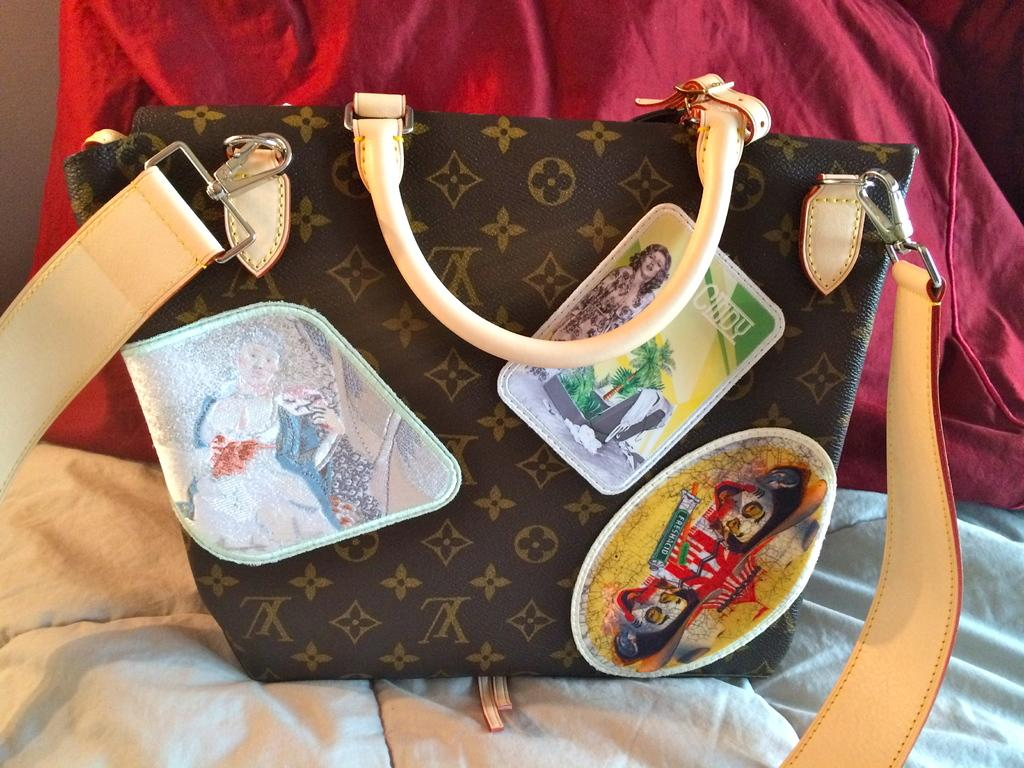What object is the main focus of the image? There is a handbag in the image. What can be seen on the surface of the handbag? There are many pictures on the handbag. What is beneath the handbag in the image? There is a white cloth beneath the handbag. What type of behavior can be observed in the bridge in the image? There is no bridge present in the image, so it is not possible to observe any behavior related to a bridge. 